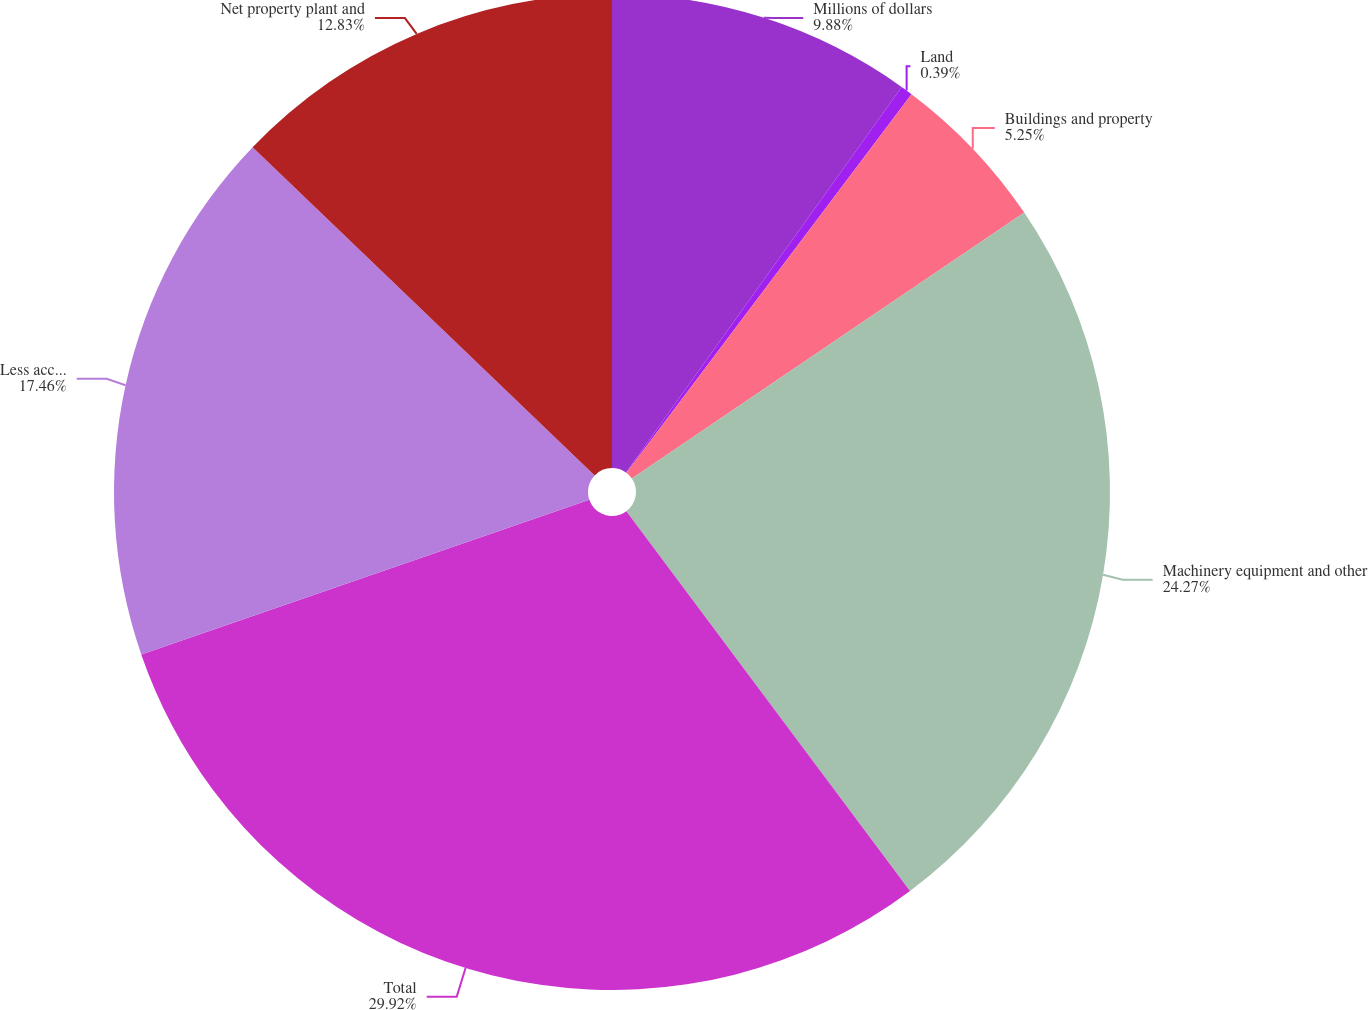Convert chart. <chart><loc_0><loc_0><loc_500><loc_500><pie_chart><fcel>Millions of dollars<fcel>Land<fcel>Buildings and property<fcel>Machinery equipment and other<fcel>Total<fcel>Less accumulated depreciation<fcel>Net property plant and<nl><fcel>9.88%<fcel>0.39%<fcel>5.25%<fcel>24.27%<fcel>29.92%<fcel>17.46%<fcel>12.83%<nl></chart> 